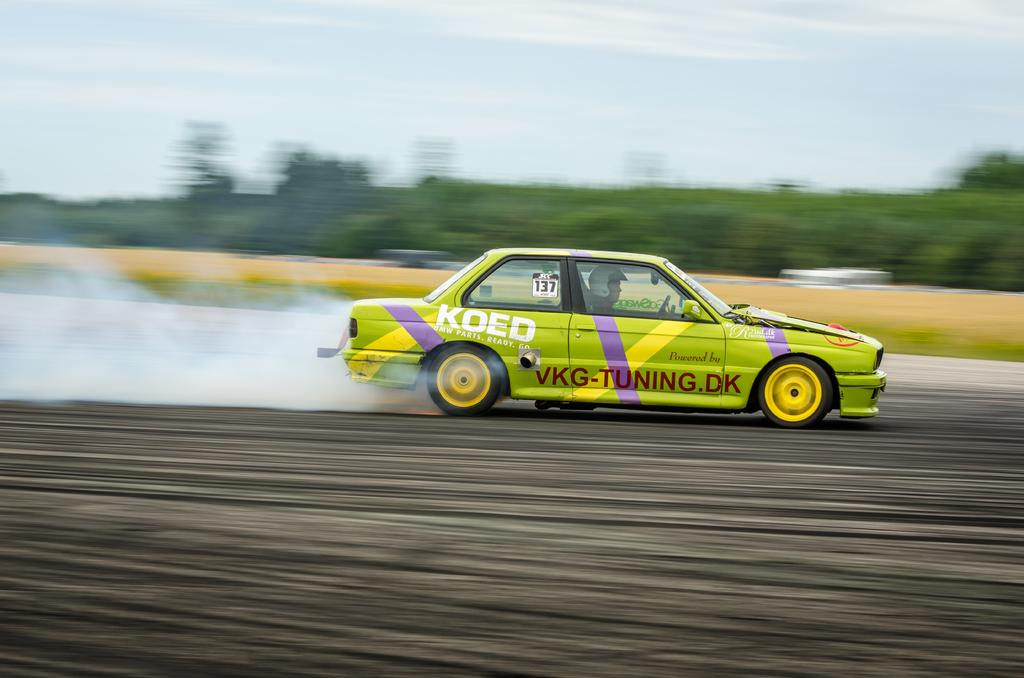What is the person in the image doing? The person is driving a car in the image. What can be seen behind the car? There is smoke behind the car. What is visible on the other side of the car? There are trees on the other side of the car. What type of wool is being used to create the class in the image? There is no class or wool present in the image. 